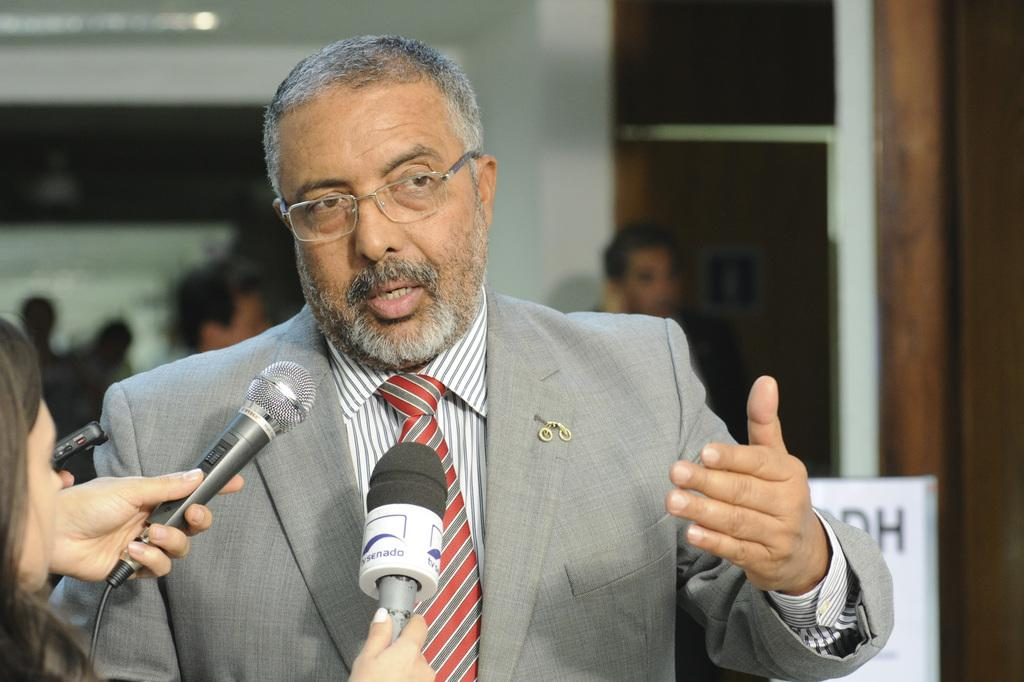Who is the main subject in the image? There is a man in the image. What is the man wearing? The man is wearing a suit. What is the man doing in the image? The man is talking to journalists. What are the journalists holding? The journalists are holding microphones. Can you describe the background of the image? The background is blurry, and there are other persons present. What type of canvas is the man painting in the image? There is no canvas present in the image, and the man is not painting. Can you describe the rat that is jumping in the background of the image? There is no rat present in the image, and no one is jumping. 